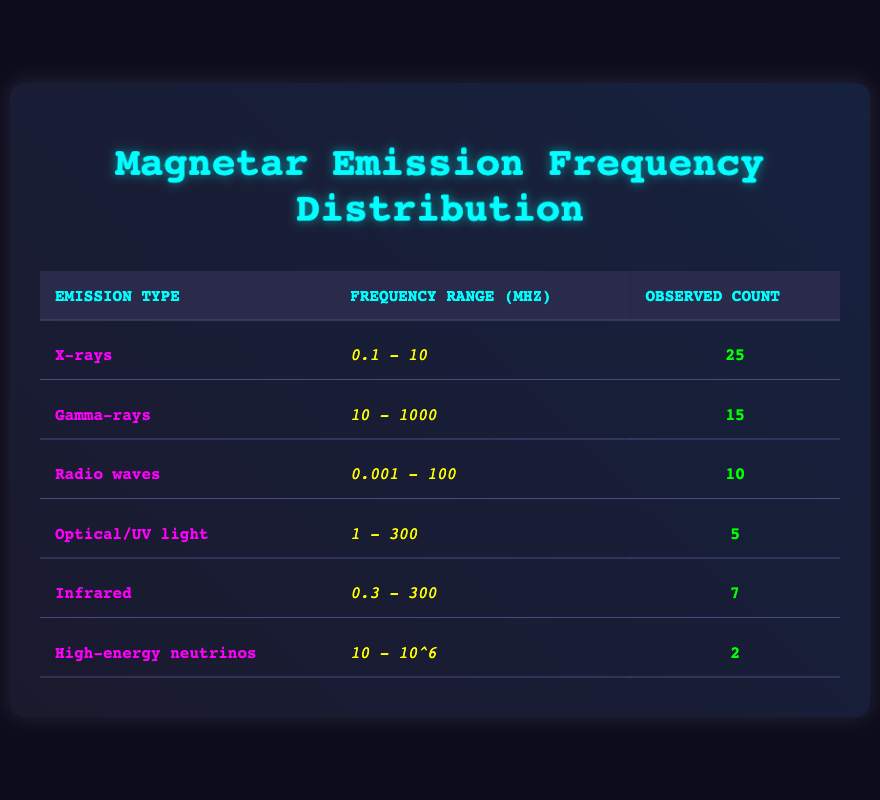What is the observed count for X-rays? The table lists the observed count for each emission type. For X-rays, the observed count is explicitly stated in the table as 25.
Answer: 25 Which emission type has the lowest observed count? Reviewing the observed counts in the table, High-energy neutrinos have the lowest count at 2, compared to all other types of emissions.
Answer: High-energy neutrinos What is the frequency range for Optical/UV light? The table provides the frequency ranges for each emission type. For Optical/UV light, the frequency range is listed as 1 - 300 mHz.
Answer: 1 - 300 mHz How many total emissions were observed across all types? To find the total observed emissions, add up all the observed counts: 25 + 15 + 10 + 5 + 7 + 2 = 64. Thus, the total observed emissions across all types is 64.
Answer: 64 Are there more counts of X-rays than Radio waves? By comparing the observed counts for both emission types in the table: X-rays have 25 counts and Radio waves have 10 counts. Thus, it is true that there are more counts of X-rays than Radio waves.
Answer: Yes What is the average observed count for all emissions? To find the average observed count, first sum all the observed counts (25 + 15 + 10 + 5 + 7 + 2 = 64) and then divide by the number of emission types (6). The average is 64/6 = 10.67.
Answer: 10.67 How many more counts do Gamma-rays have compared to Infrared? To find the difference between Gamma-rays and Infrared, we look at their observed counts: Gamma-rays have 15 counts, and Infrared has 7 counts. The difference is 15 - 7 = 8, meaning Gamma-rays have 8 more counts than Infrared.
Answer: 8 Which emission type falls into the highest frequency range (above 1000 mHz)? The table states that High-energy neutrinos have a frequency range of 10 - 10^6, which is the only emission type with a range above 1000 mHz.
Answer: High-energy neutrinos Is the observed count for Infrared greater than that of Optical/UV light? According to the table, Infrared has an observed count of 7 while Optical/UV light has 5. Since 7 is greater than 5, the statement is true.
Answer: Yes 